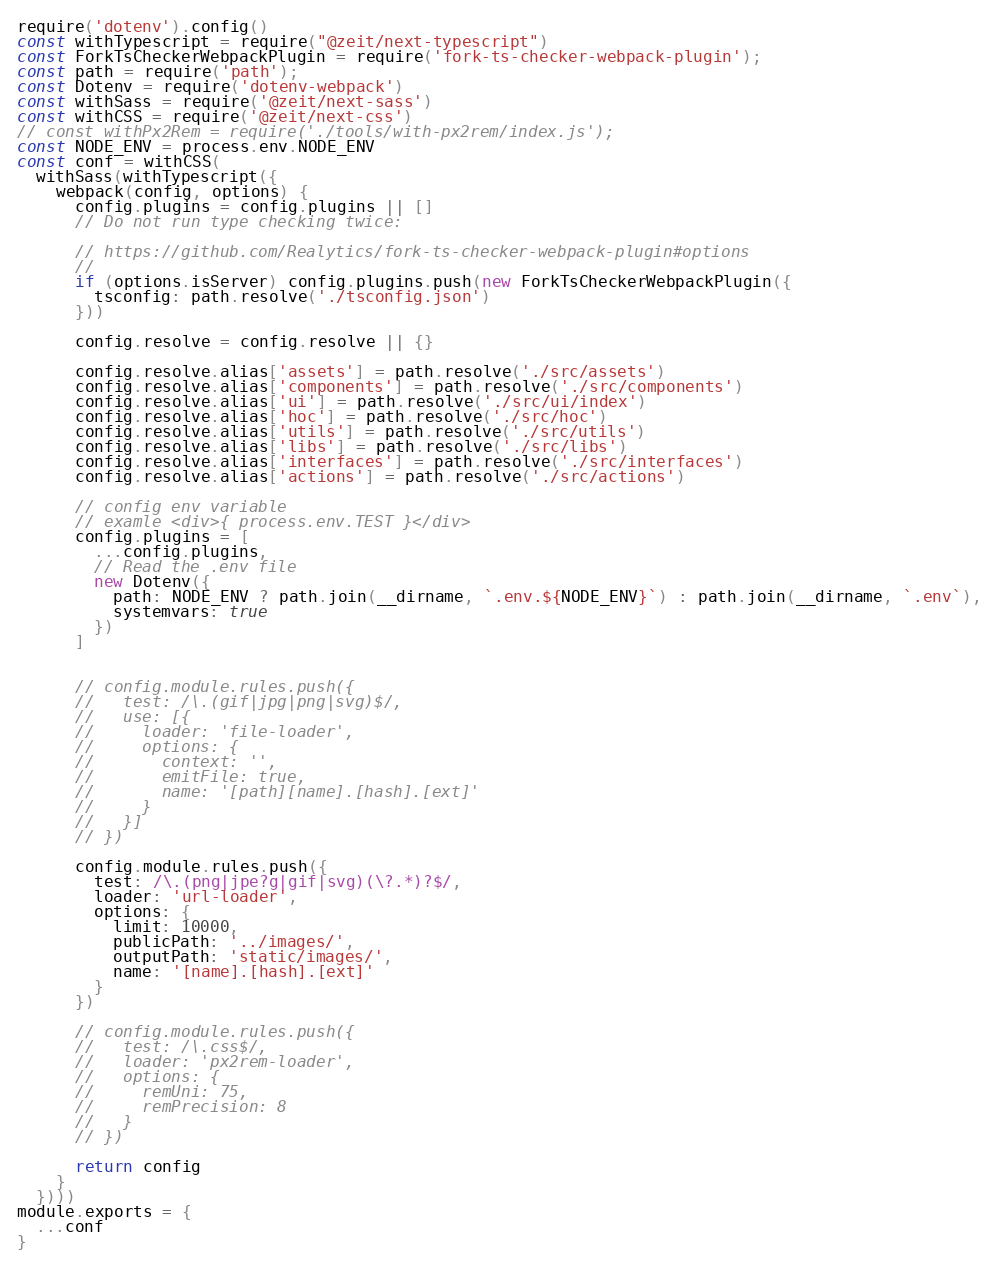Convert code to text. <code><loc_0><loc_0><loc_500><loc_500><_JavaScript_>require('dotenv').config()
const withTypescript = require("@zeit/next-typescript")
const ForkTsCheckerWebpackPlugin = require('fork-ts-checker-webpack-plugin');
const path = require('path');
const Dotenv = require('dotenv-webpack')
const withSass = require('@zeit/next-sass')
const withCSS = require('@zeit/next-css')
// const withPx2Rem = require('./tools/with-px2rem/index.js');
const NODE_ENV = process.env.NODE_ENV
const conf = withCSS(
  withSass(withTypescript({
    webpack(config, options) {
      config.plugins = config.plugins || []
      // Do not run type checking twice:

      // https://github.com/Realytics/fork-ts-checker-webpack-plugin#options
      // 
      if (options.isServer) config.plugins.push(new ForkTsCheckerWebpackPlugin({
        tsconfig: path.resolve('./tsconfig.json')
      }))

      config.resolve = config.resolve || {}

      config.resolve.alias['assets'] = path.resolve('./src/assets')
      config.resolve.alias['components'] = path.resolve('./src/components')
      config.resolve.alias['ui'] = path.resolve('./src/ui/index')
      config.resolve.alias['hoc'] = path.resolve('./src/hoc')
      config.resolve.alias['utils'] = path.resolve('./src/utils')
      config.resolve.alias['libs'] = path.resolve('./src/libs')
      config.resolve.alias['interfaces'] = path.resolve('./src/interfaces')
      config.resolve.alias['actions'] = path.resolve('./src/actions')

      // config env variable
      // examle <div>{ process.env.TEST }</div>
      config.plugins = [
        ...config.plugins,
        // Read the .env file
        new Dotenv({
          path: NODE_ENV ? path.join(__dirname, `.env.${NODE_ENV}`) : path.join(__dirname, `.env`),
          systemvars: true
        })
      ]


      // config.module.rules.push({
      //   test: /\.(gif|jpg|png|svg)$/,
      //   use: [{
      //     loader: 'file-loader',
      //     options: {
      //       context: '',
      //       emitFile: true,
      //       name: '[path][name].[hash].[ext]'
      //     }
      //   }]
      // })

      config.module.rules.push({
        test: /\.(png|jpe?g|gif|svg)(\?.*)?$/,
        loader: 'url-loader',
        options: {
          limit: 10000,
          publicPath: '../images/',
          outputPath: 'static/images/',
          name: '[name].[hash].[ext]'
        }
      })

      // config.module.rules.push({
      //   test: /\.css$/,
      //   loader: 'px2rem-loader',
      //   options: {
      //     remUni: 75,
      //     remPrecision: 8
      //   }
      // })

      return config
    }
  })))
module.exports = {
  ...conf
}</code> 